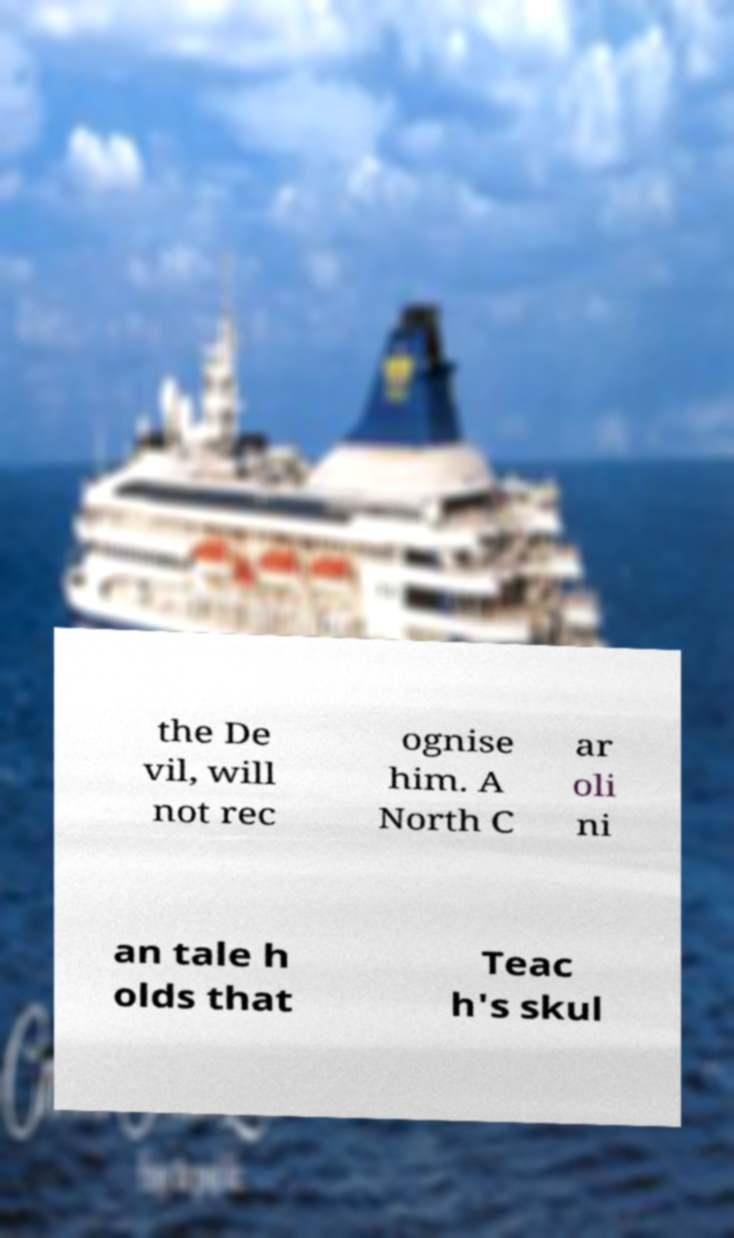For documentation purposes, I need the text within this image transcribed. Could you provide that? the De vil, will not rec ognise him. A North C ar oli ni an tale h olds that Teac h's skul 